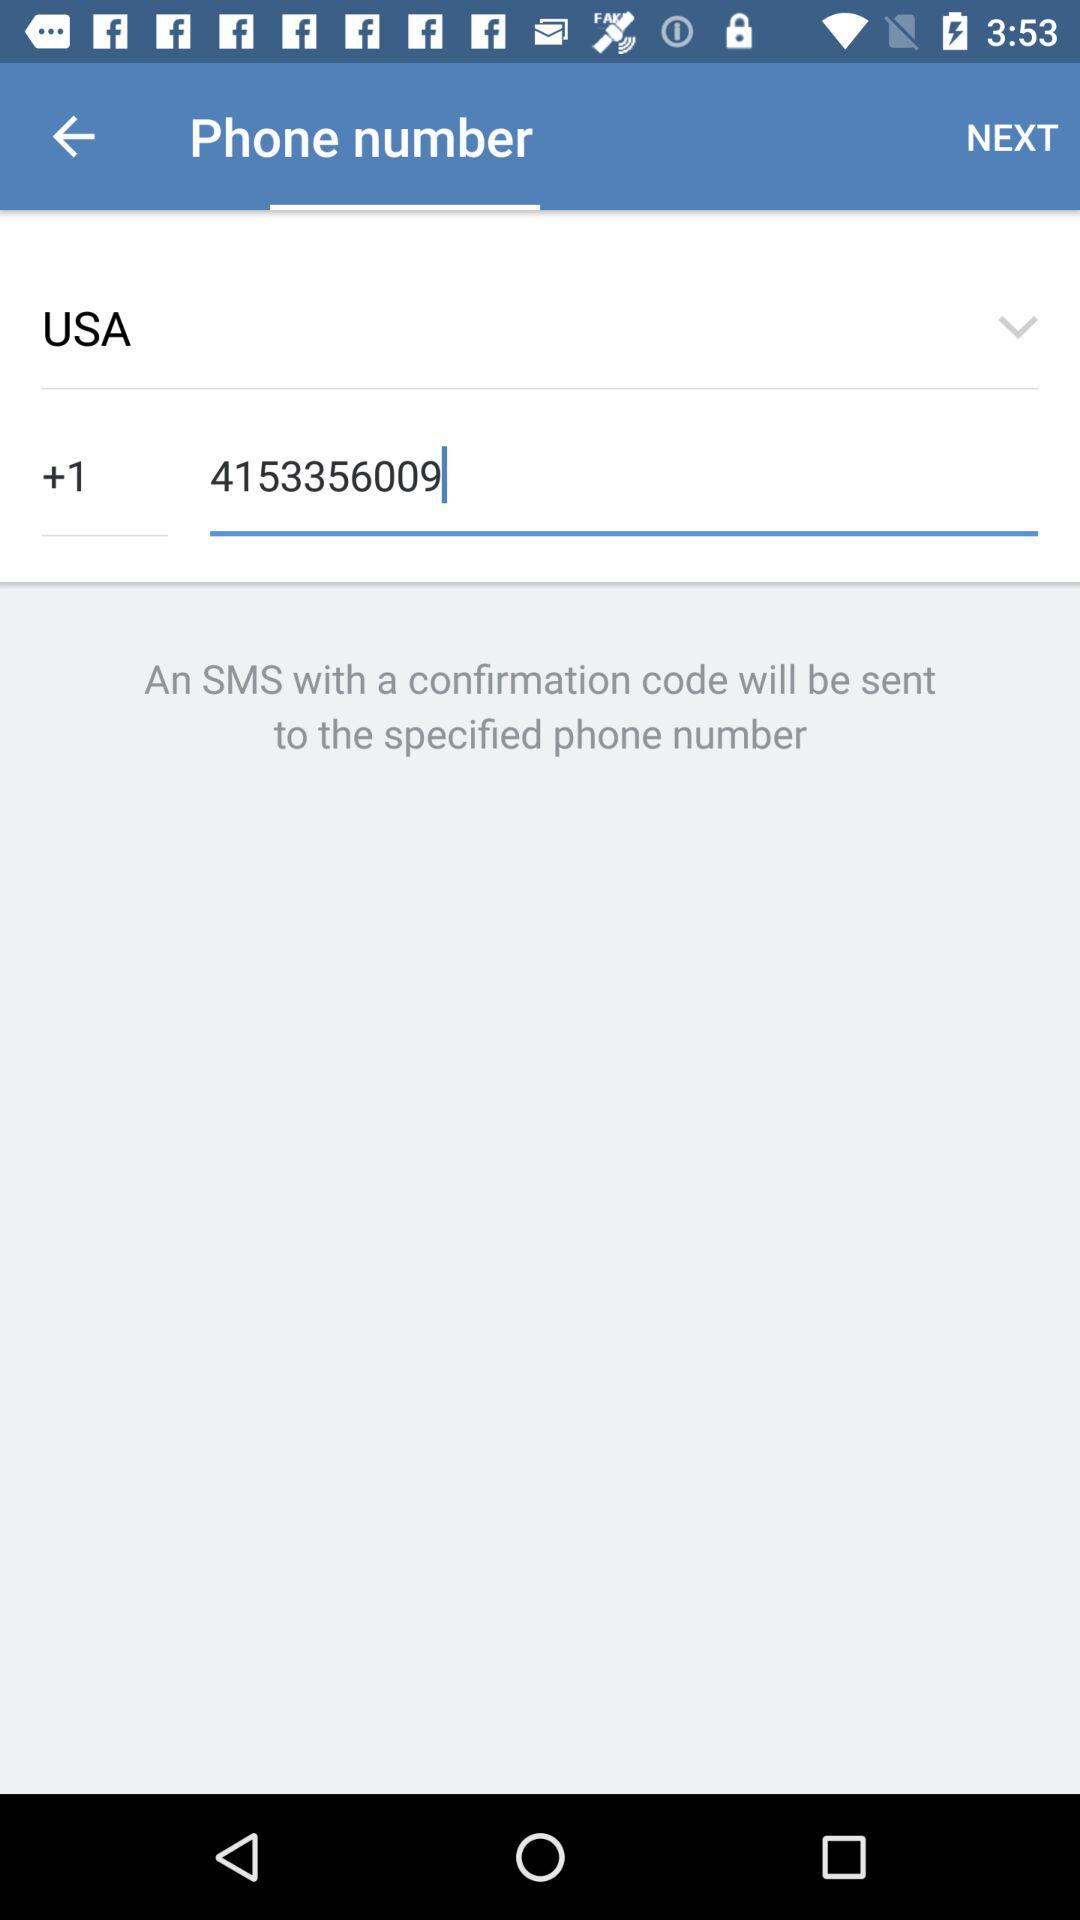How many digits are in the phone number that has been entered?
Answer the question using a single word or phrase. 10 